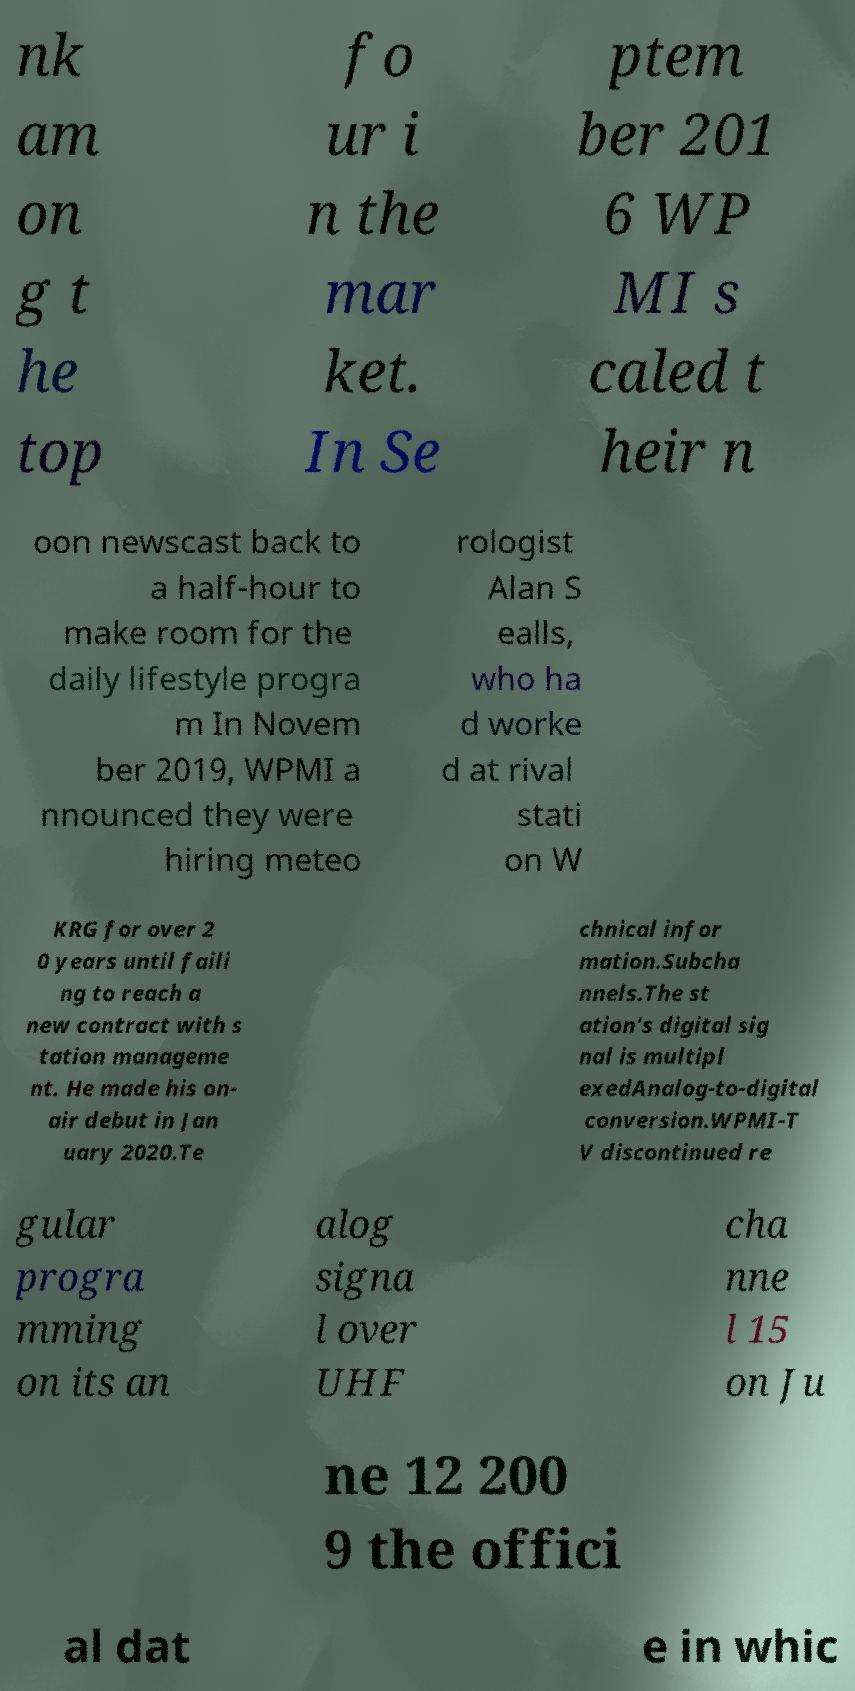Please read and relay the text visible in this image. What does it say? nk am on g t he top fo ur i n the mar ket. In Se ptem ber 201 6 WP MI s caled t heir n oon newscast back to a half-hour to make room for the daily lifestyle progra m In Novem ber 2019, WPMI a nnounced they were hiring meteo rologist Alan S ealls, who ha d worke d at rival stati on W KRG for over 2 0 years until faili ng to reach a new contract with s tation manageme nt. He made his on- air debut in Jan uary 2020.Te chnical infor mation.Subcha nnels.The st ation's digital sig nal is multipl exedAnalog-to-digital conversion.WPMI-T V discontinued re gular progra mming on its an alog signa l over UHF cha nne l 15 on Ju ne 12 200 9 the offici al dat e in whic 